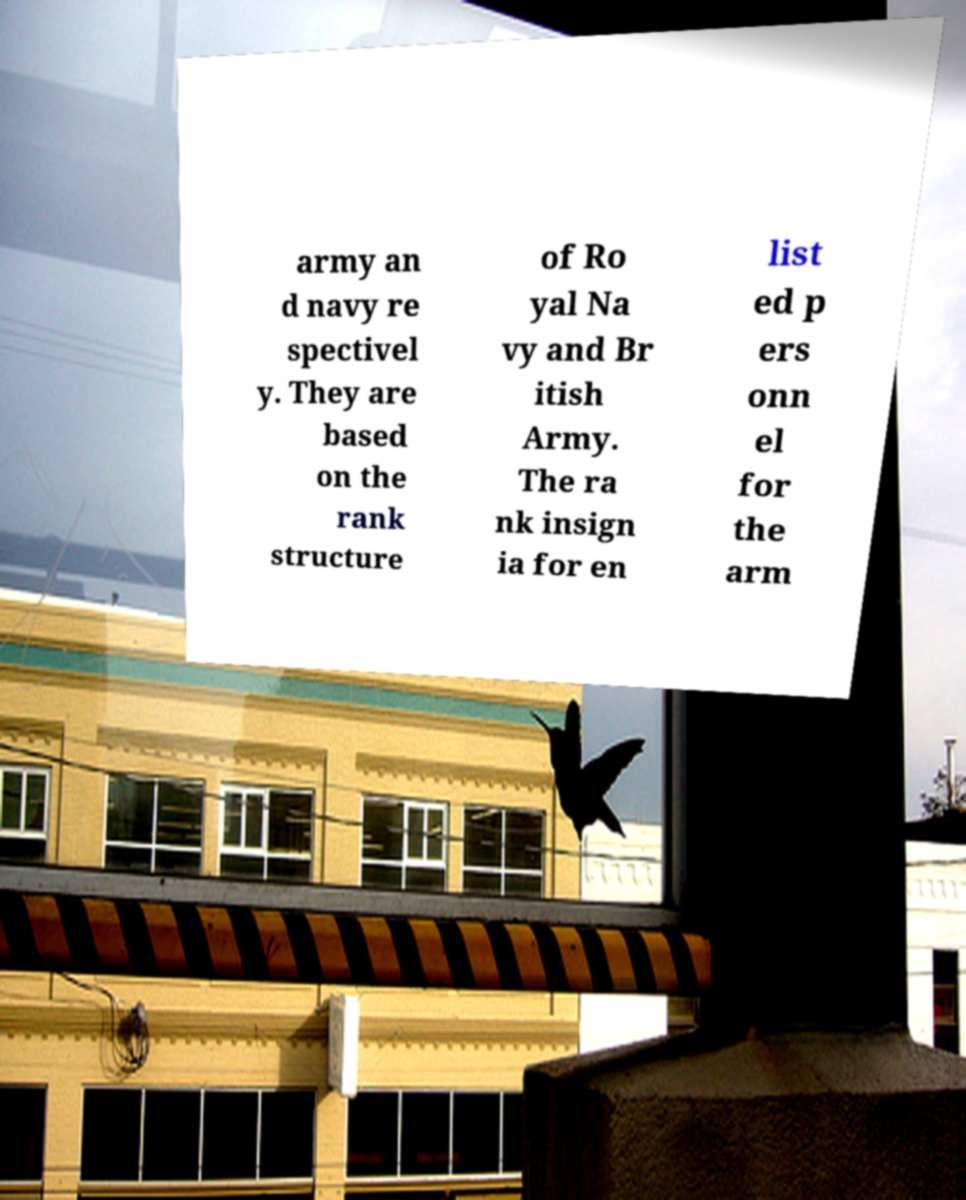There's text embedded in this image that I need extracted. Can you transcribe it verbatim? army an d navy re spectivel y. They are based on the rank structure of Ro yal Na vy and Br itish Army. The ra nk insign ia for en list ed p ers onn el for the arm 